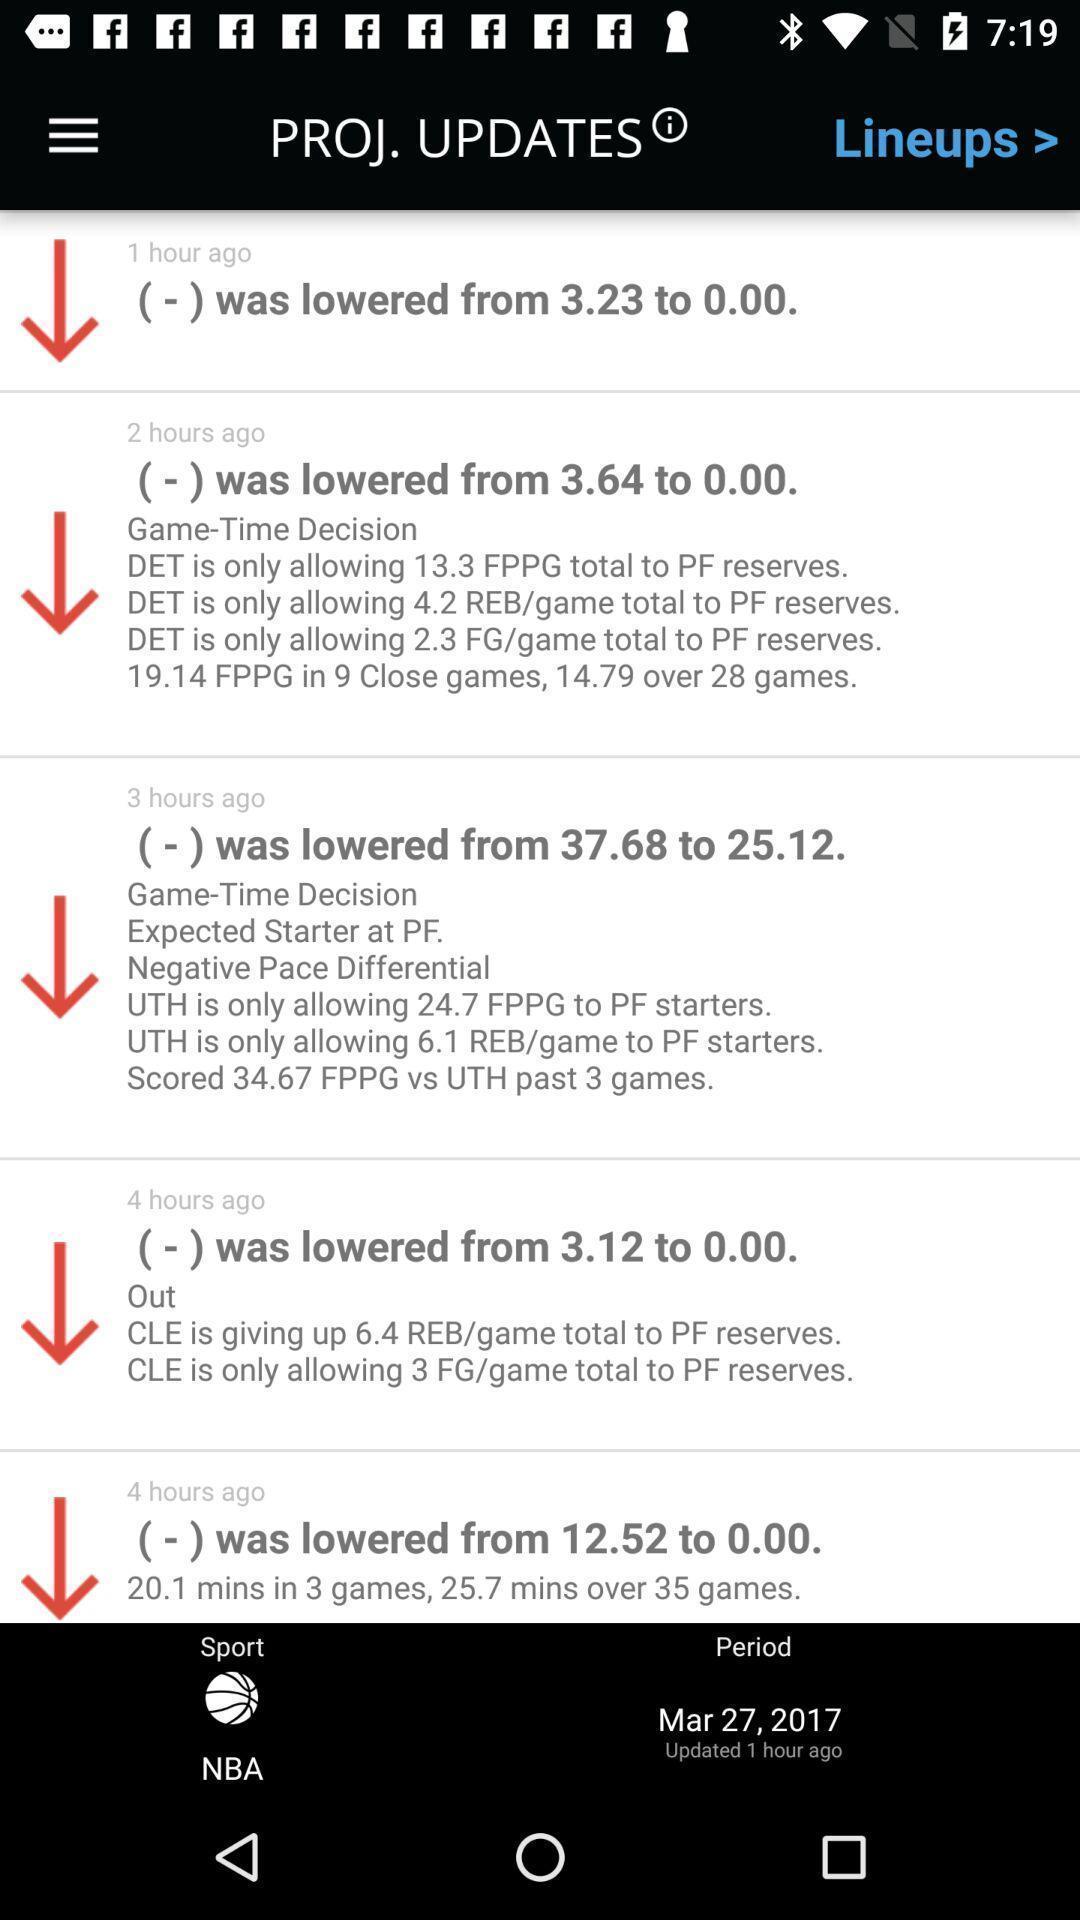Explain the elements present in this screenshot. Page displaying various updates. 